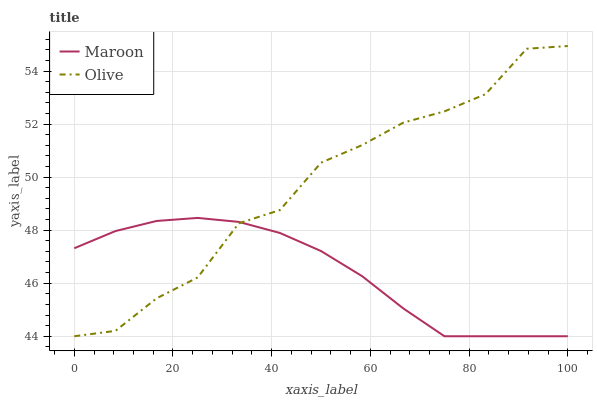Does Maroon have the maximum area under the curve?
Answer yes or no. No. Is Maroon the roughest?
Answer yes or no. No. Does Maroon have the highest value?
Answer yes or no. No. 